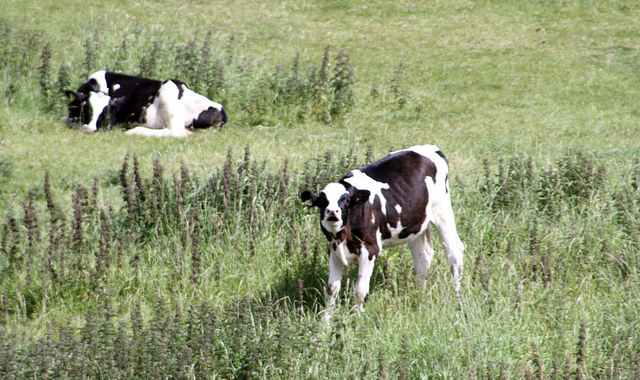<image>What is the sex of the animals? I don't know the sex of the animals. It can be either male or female. What is the sex of the animals? I don't know the sex of the animals. It can be both male and female. 